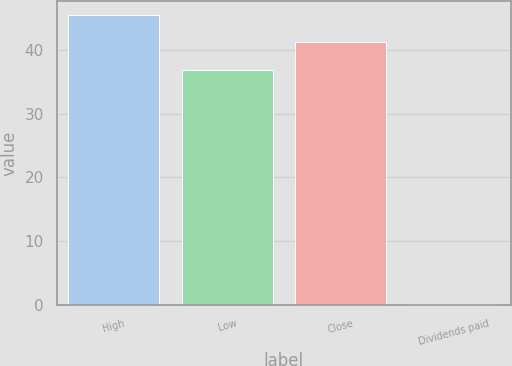<chart> <loc_0><loc_0><loc_500><loc_500><bar_chart><fcel>High<fcel>Low<fcel>Close<fcel>Dividends paid<nl><fcel>45.39<fcel>36.74<fcel>41.27<fcel>0.2<nl></chart> 